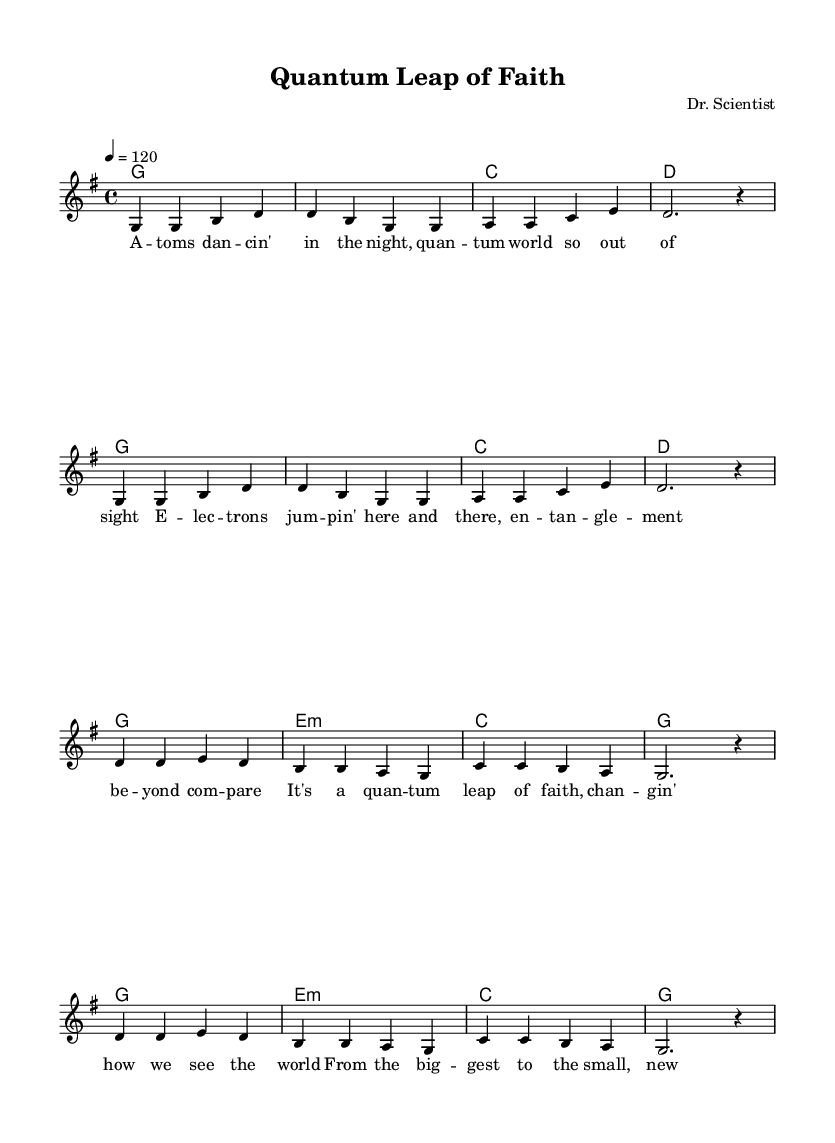What is the key signature of this music? The key signature is G major, which has one sharp (F#).
Answer: G major What is the time signature of this piece? The time signature is 4/4, indicating that there are four beats per measure.
Answer: 4/4 What is the tempo of the piece? The tempo marking indicates a speed of 120 beats per minute.
Answer: 120 How many measures are in the melody section? The melody section consists of 16 measures, following the repeated structure in the score.
Answer: 16 What is the title of the song? The title, found in the header, is "Quantum Leap of Faith."
Answer: Quantum Leap of Faith Which musical key does the song end on? The song concludes on the G major chord, which corresponds to the tonic in this key.
Answer: G How does the song relate to science? The lyrics reference scientific concepts like quantum entanglement, highlighting the impact of these discoveries on perception.
Answer: Quantum entanglement 